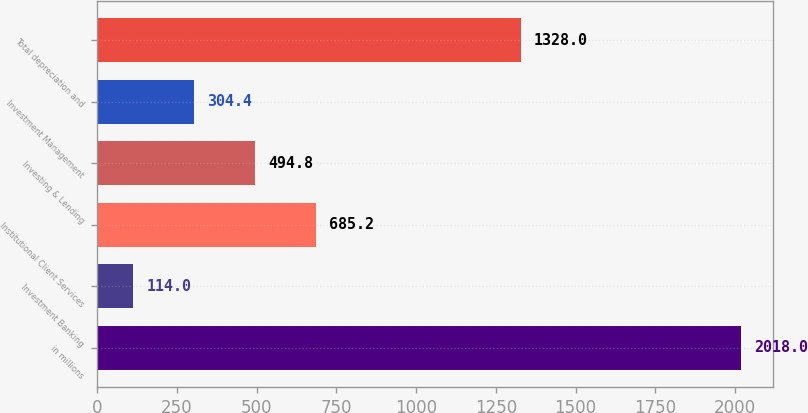Convert chart to OTSL. <chart><loc_0><loc_0><loc_500><loc_500><bar_chart><fcel>in millions<fcel>Investment Banking<fcel>Institutional Client Services<fcel>Investing & Lending<fcel>Investment Management<fcel>Total depreciation and<nl><fcel>2018<fcel>114<fcel>685.2<fcel>494.8<fcel>304.4<fcel>1328<nl></chart> 